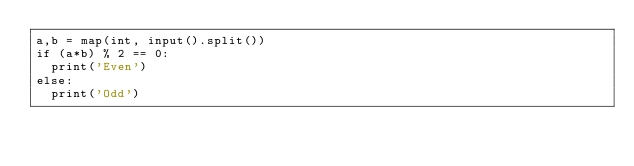<code> <loc_0><loc_0><loc_500><loc_500><_Python_>a,b = map(int, input().split())
if (a*b) % 2 == 0:
  print('Even')
else:
  print('Odd')</code> 